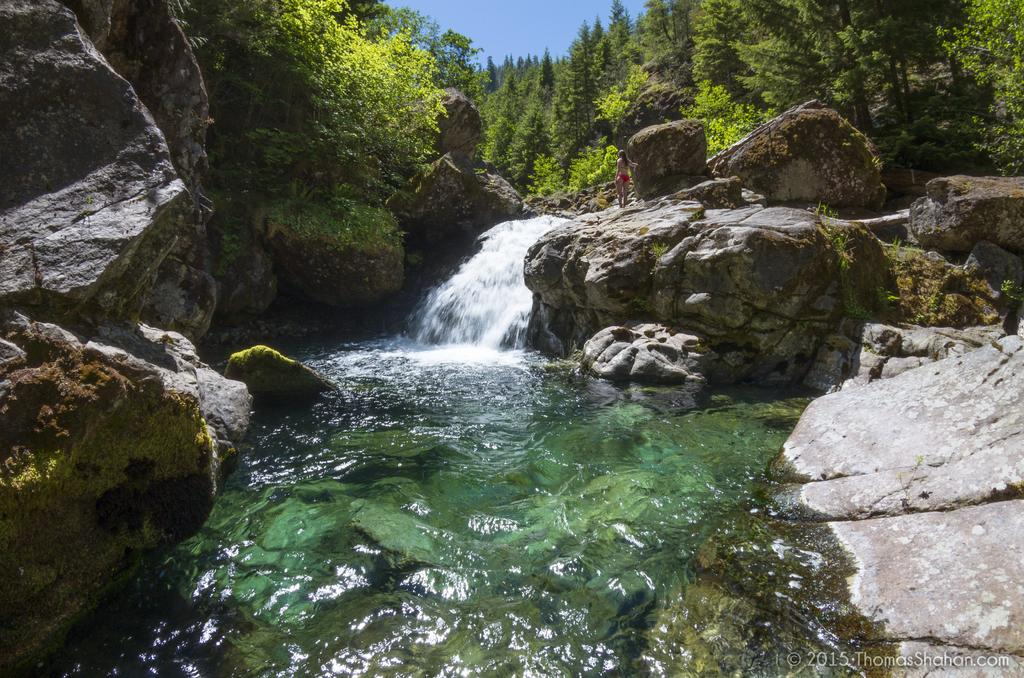What type of natural elements can be seen in the image? There are rocks, water, and trees visible in the image. What is the person in the image doing? The person is standing on a rock in the image. What is the color of the sky in the image? The sky is blue in color. How many girls are wearing gloves in the image? There are no girls or gloves present in the image. What type of emotion is being expressed by the rocks in the image? Rocks do not express emotions, so this question cannot be answered. 